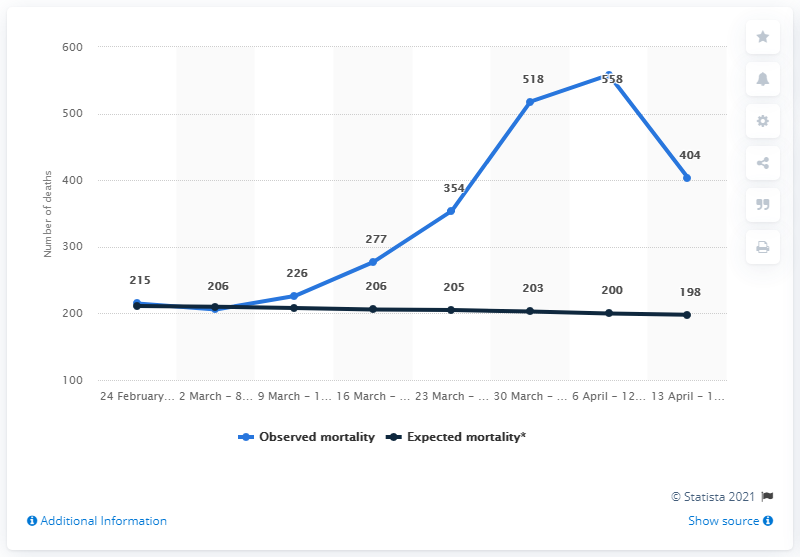Highlight a few significant elements in this photo. There were 558 deaths in the Brussels-Capital Region during the COVID-19 pandemic. Based on forecasts, it was expected that approximately 200 deaths would occur in the Brussels-Capital Region between April 6 and April 12, 2020. 